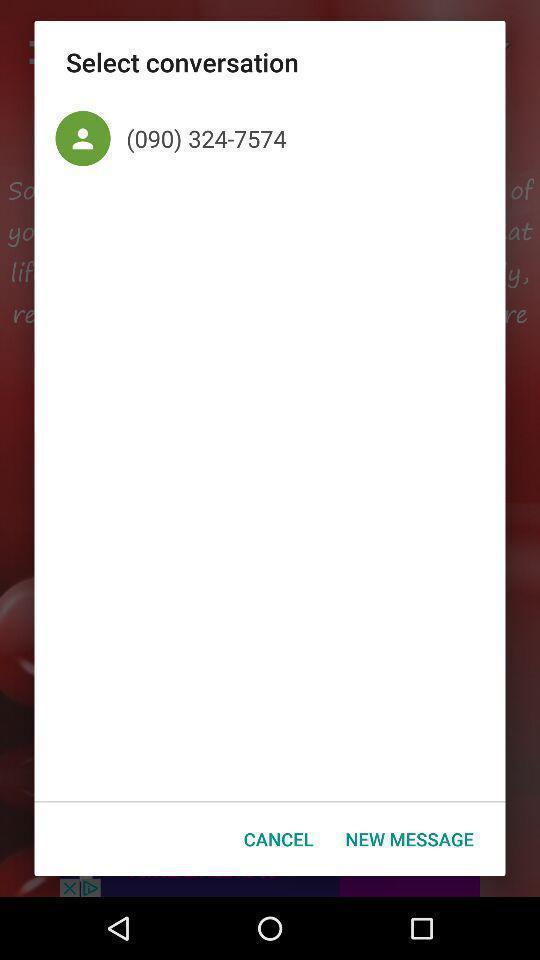Explain the elements present in this screenshot. Pop-up with messaging related options. 